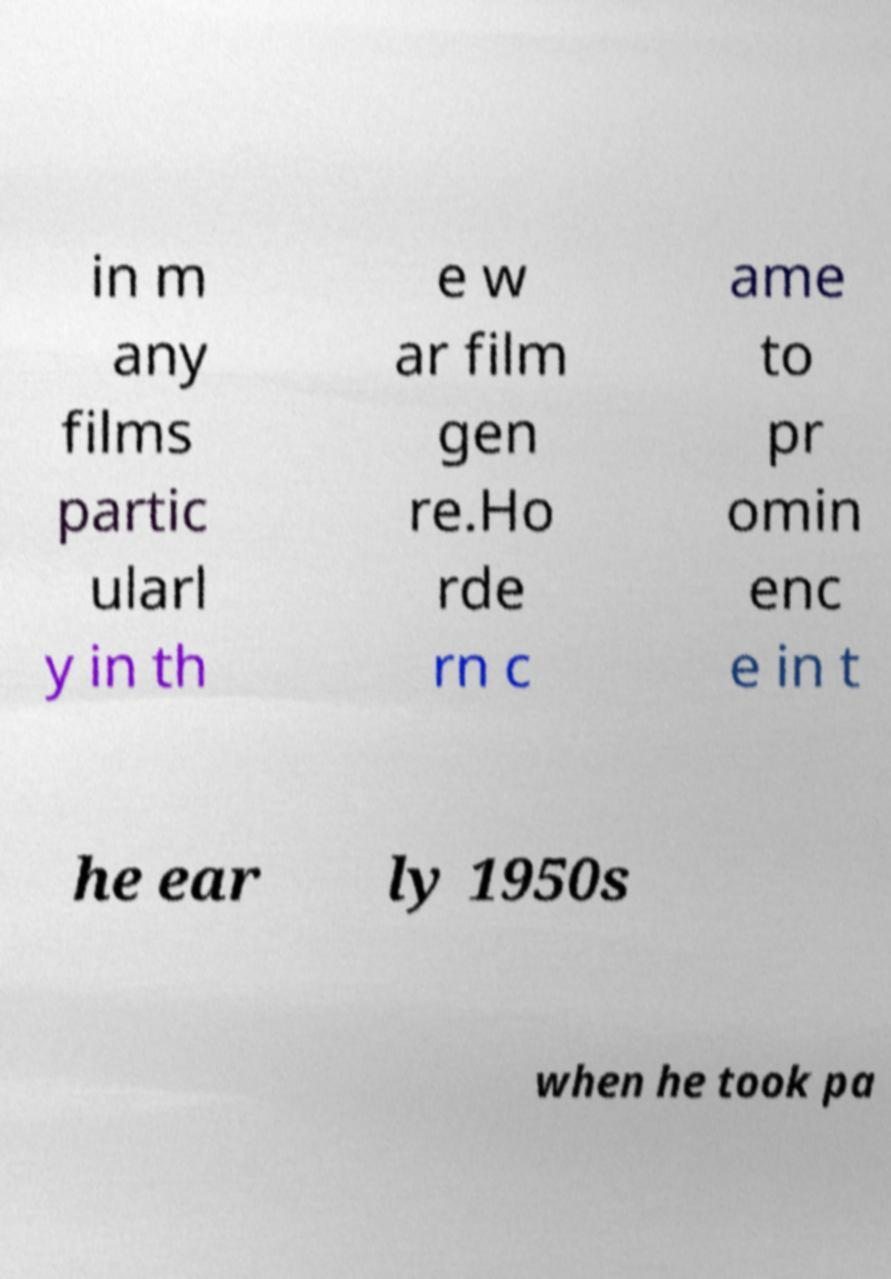For documentation purposes, I need the text within this image transcribed. Could you provide that? in m any films partic ularl y in th e w ar film gen re.Ho rde rn c ame to pr omin enc e in t he ear ly 1950s when he took pa 